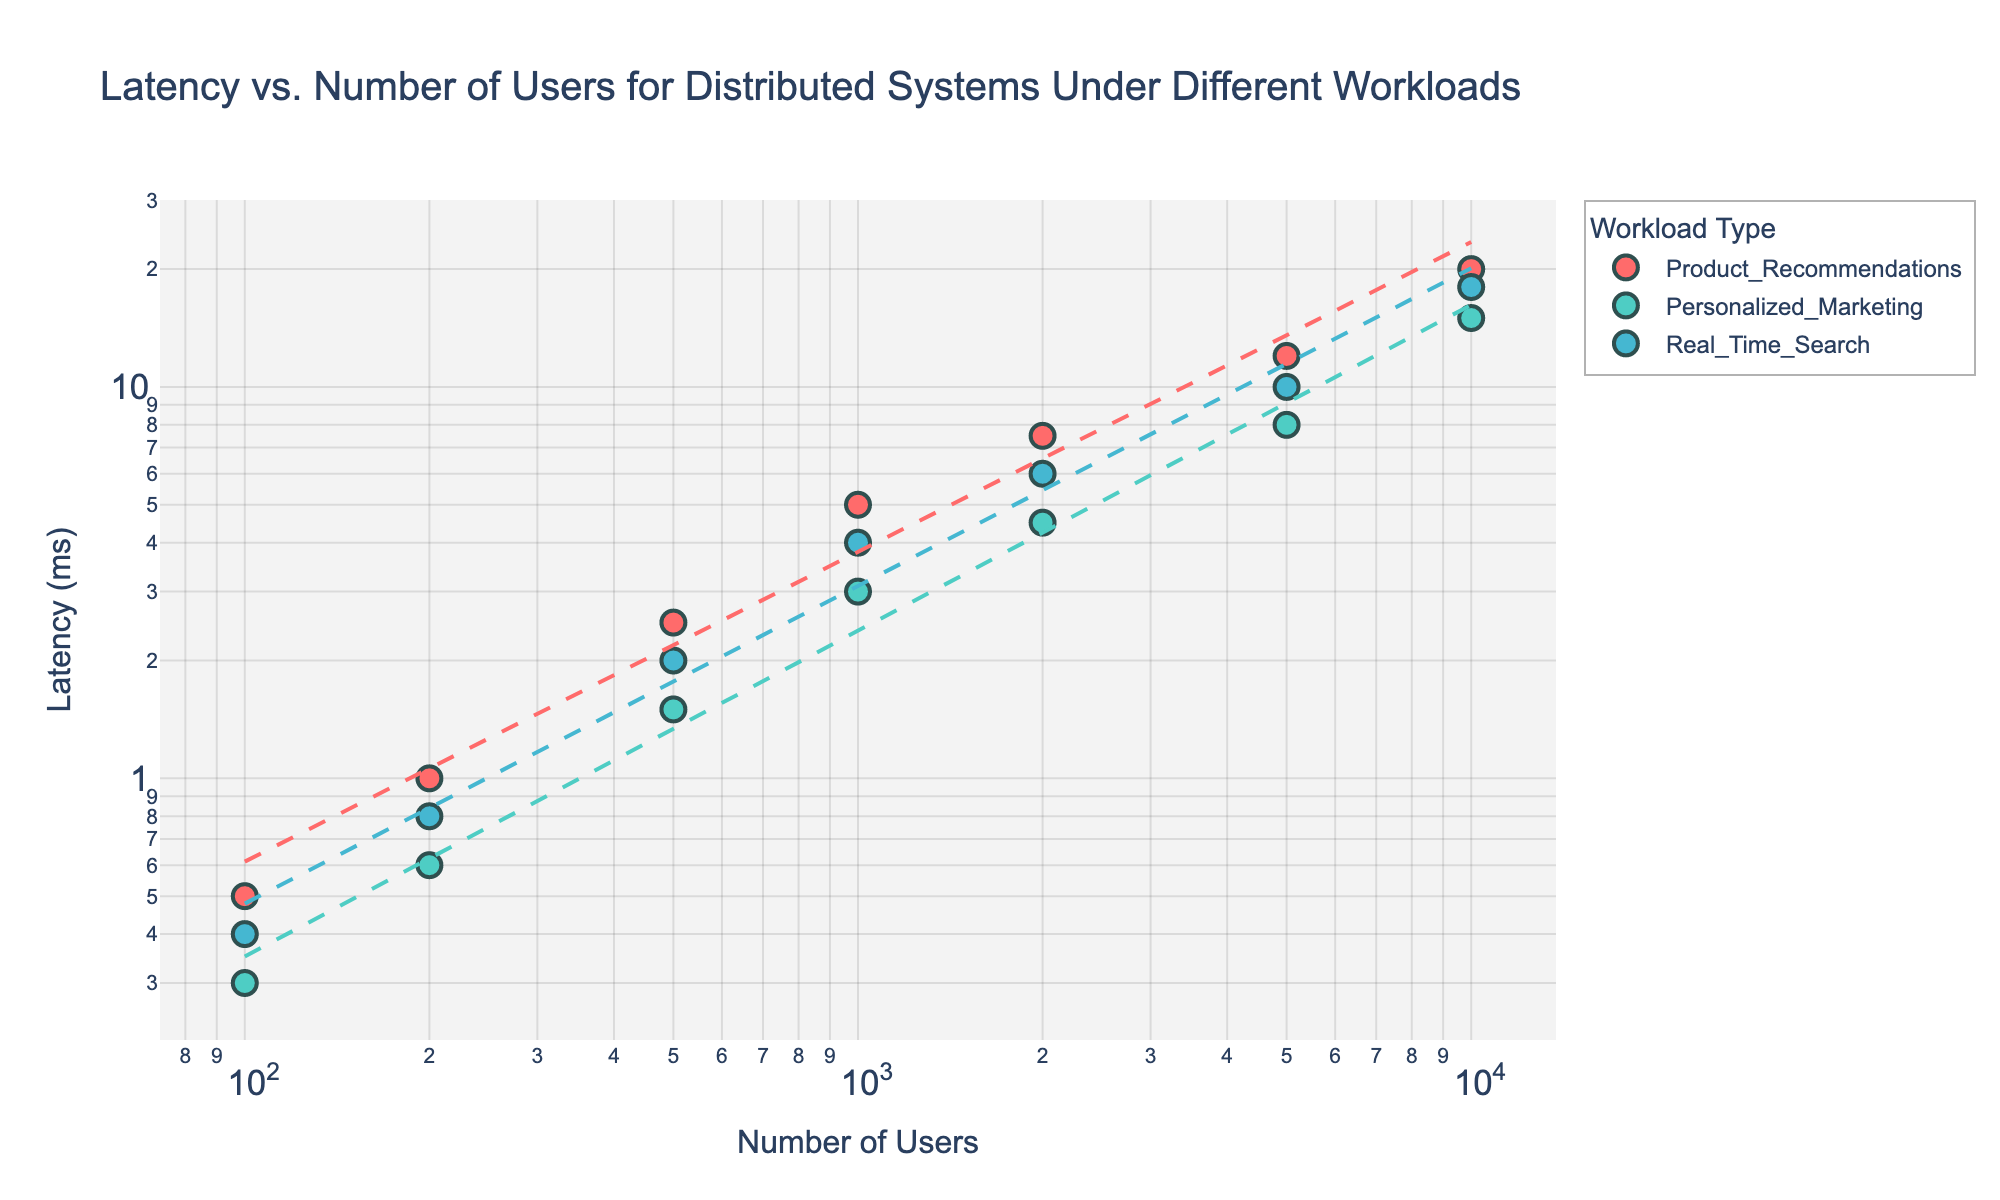How many different workloads are represented in the figure? There are three distinct colors present in the scatter plot, each representing a different workload: Product Recommendations, Personalized Marketing, and Real-Time Search.
Answer: 3 What is the title of the figure? The title is located at the top of the chart.
Answer: Latency vs. Number of Users for Distributed Systems Under Different Workloads What is the latency for 2000 users in the Personalized Marketing workload? Locate the data points for the Personalized Marketing workload and find the point where the number of users is 2000. The corresponding latency value on the y-axis is 4.5 ms.
Answer: 4.5 ms How does the latency for 10000 users in Real-Time Search compare to Product Recommendations? Identify the data points for both Real-Time Search and Product Recommendations for 10000 users: Real-Time Search has a latency of 18.0 ms, while Product Recommendations has a latency of 20.0 ms.
Answer: Real-Time Search latency is lower Which workload shows the steepest increase in latency as the number of users increases? By analyzing the slope of the trend lines, the Product Recommendations workload has the steepest slope, indicating the highest increase in latency with the number of users.
Answer: Product Recommendations What is the trend line equation for Product Recommendations? By fitting a linear model in log-log space, the trend line equation for Product Recommendations corresponds to its unique trend line on the graph.
Answer: log(y) = log(x) + c (where c is a constant) Compare the latencies for 5000 users in all workloads. Which has the lowest latency? Locate the data points for 5000 users across all workloads: Product Recommendations (12.0 ms), Personalized Marketing (8.0 ms), and Real-Time Search (10.0 ms). The lowest latency is for Personalized Marketing.
Answer: Personalized Marketing What is the average latency for 1000 users across all workloads? Find the latency for 1000 users in each workload: Product Recommendations (5.0 ms), Personalized Marketing (3.0 ms), Real-Time Search (4.0 ms). Calculate the average: (5.0 + 3.0 + 4.0) / 3 = 4.0 ms.
Answer: 4.0 ms What general trend can you observe for all workloads as the number of users increases? All workloads show an upward trend, indicating that latency increases with the number of users. This is evident from the positive slopes of all trend lines.
Answer: Latency increases 